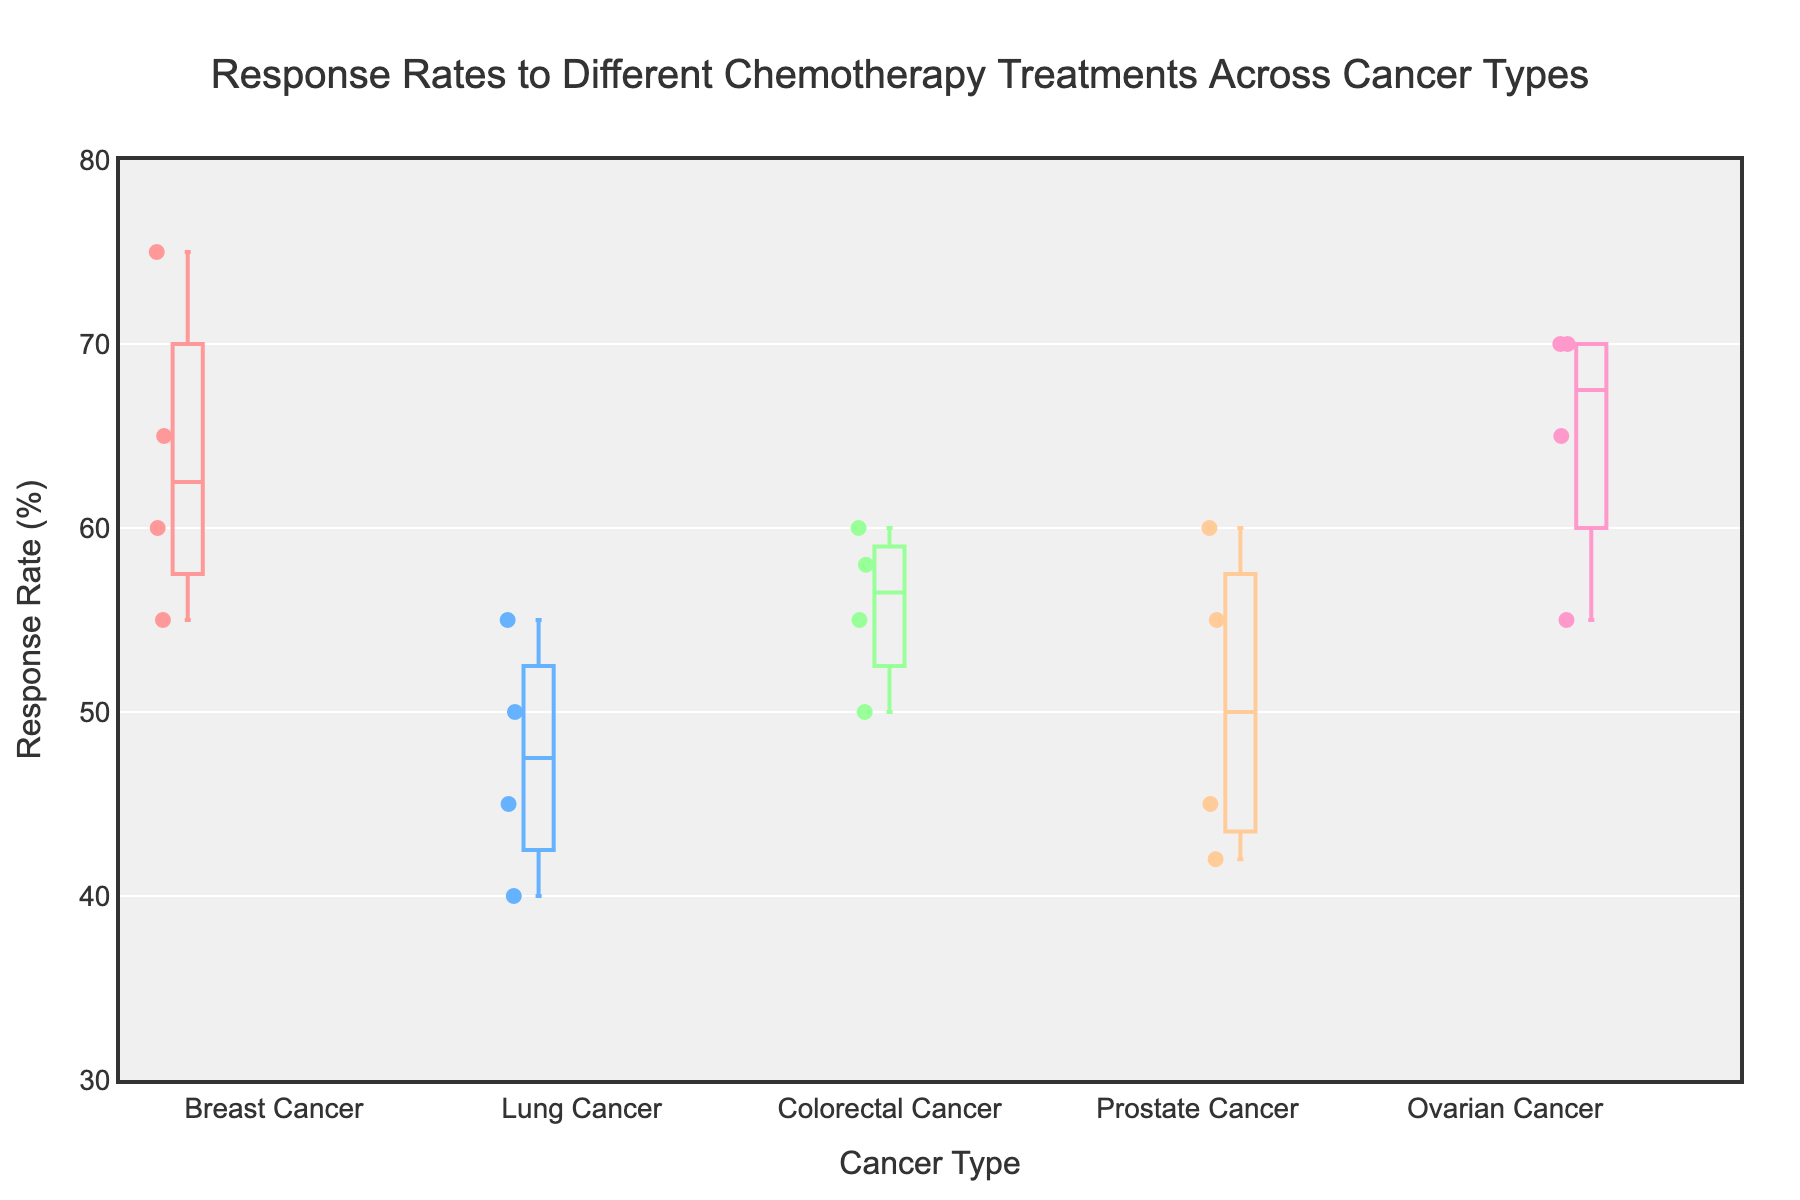What's the title of the figure? The title of the figure can be found at the top of the plot. It provides context about what the figure represents.
Answer: Response Rates to Different Chemotherapy Treatments Across Cancer Types What is the range of the y-axis in the plot? By examining the y-axis, you can see the numerical labels that indicate the range it covers.
Answer: 30 to 80 Which cancer type shows the highest response rate and what is its value? Look at the box plots for each cancer type and identify the one with the highest top whisker value.
Answer: Ovarian Cancer, 70% How many cancer types are represented in the plot? By counting the distinct boxes or the x-axis labels, we can determine the number of cancer types.
Answer: 5 Which cancer type has the most diverse range of response rates? To find this, identify the cancer type with the longest box plot (including whiskers), indicating a wide range of response rates.
Answer: Lung Cancer Which cancer type appears to have the most consistent (least variable) response rates? Look for the box plot with the smallest interquartile range (IQR), indicating minimal variation in response rates.
Answer: Breast Cancer Between Breast Cancer and Colorectal Cancer, which has a higher median response rate? Locate the line inside the box plot for both Breast and Colorectal Cancer to see which is higher.
Answer: Breast Cancer What is the median response rate for Prostate Cancer? Identify the line inside the Prostate Cancer box plot and read the corresponding y-axis value.
Answer: 48.5% Which cancer type has a response rate outlier? Check if any of the box plots have points outside of the whiskers, indicating outliers.
Answer: No visible outliers in the plot 